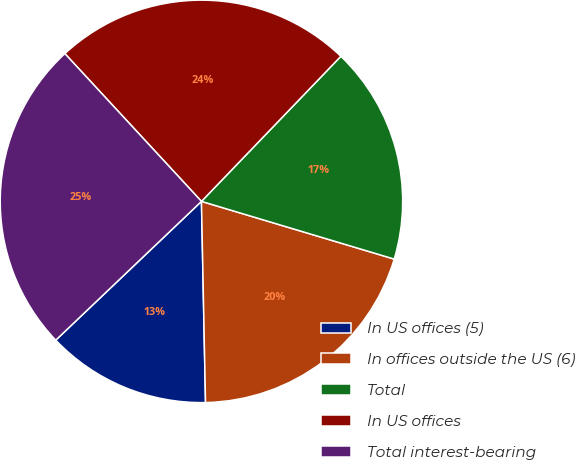<chart> <loc_0><loc_0><loc_500><loc_500><pie_chart><fcel>In US offices (5)<fcel>In offices outside the US (6)<fcel>Total<fcel>In US offices<fcel>Total interest-bearing<nl><fcel>13.21%<fcel>20.05%<fcel>17.45%<fcel>24.06%<fcel>25.24%<nl></chart> 